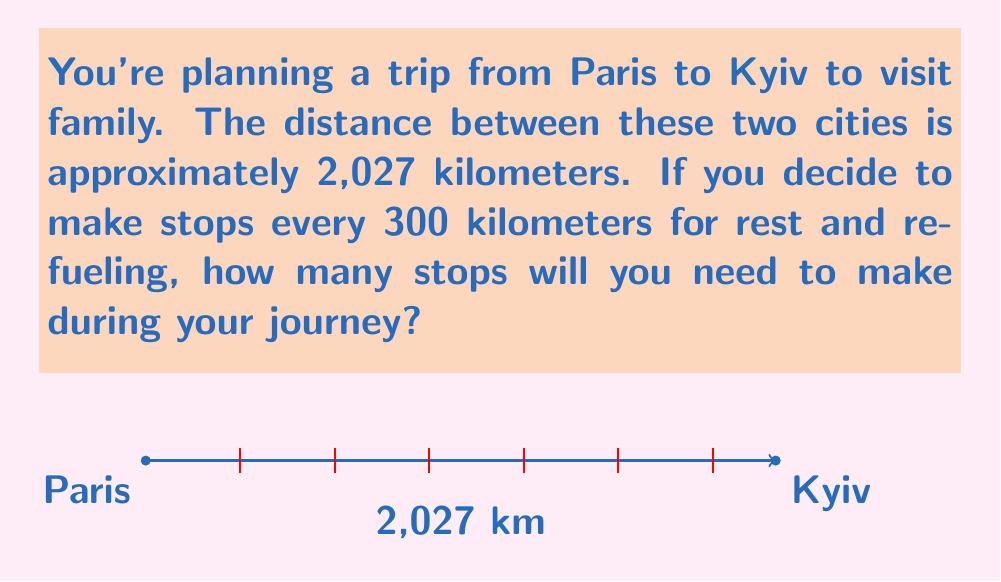Solve this math problem. To solve this problem, we need to follow these steps:

1) First, we need to determine how many complete 300 km segments fit into the total distance:

   $$ \text{Number of complete segments} = \left\lfloor\frac{\text{Total distance}}{\text{Distance between stops}}\right\rfloor $$
   
   $$ = \left\lfloor\frac{2027}{300}\right\rfloor = \lfloor 6.75666...\rfloor = 6 $$

   The floor function $\lfloor \rfloor$ gives us the largest integer less than or equal to the result.

2) This gives us the number of stops we need to make, but we need to check if there's a significant distance left after the last stop:

   $$ \text{Remaining distance} = 2027 - (6 \times 300) = 227 \text{ km} $$

3) Since 227 km is more than 75% of our 300 km interval, we should make one more stop for safety.

4) Therefore, the total number of stops is:

   $$ \text{Total stops} = 6 + 1 = 7 $$

Thus, you will need to make 7 stops during your journey from Paris to Kyiv.
Answer: 7 stops 